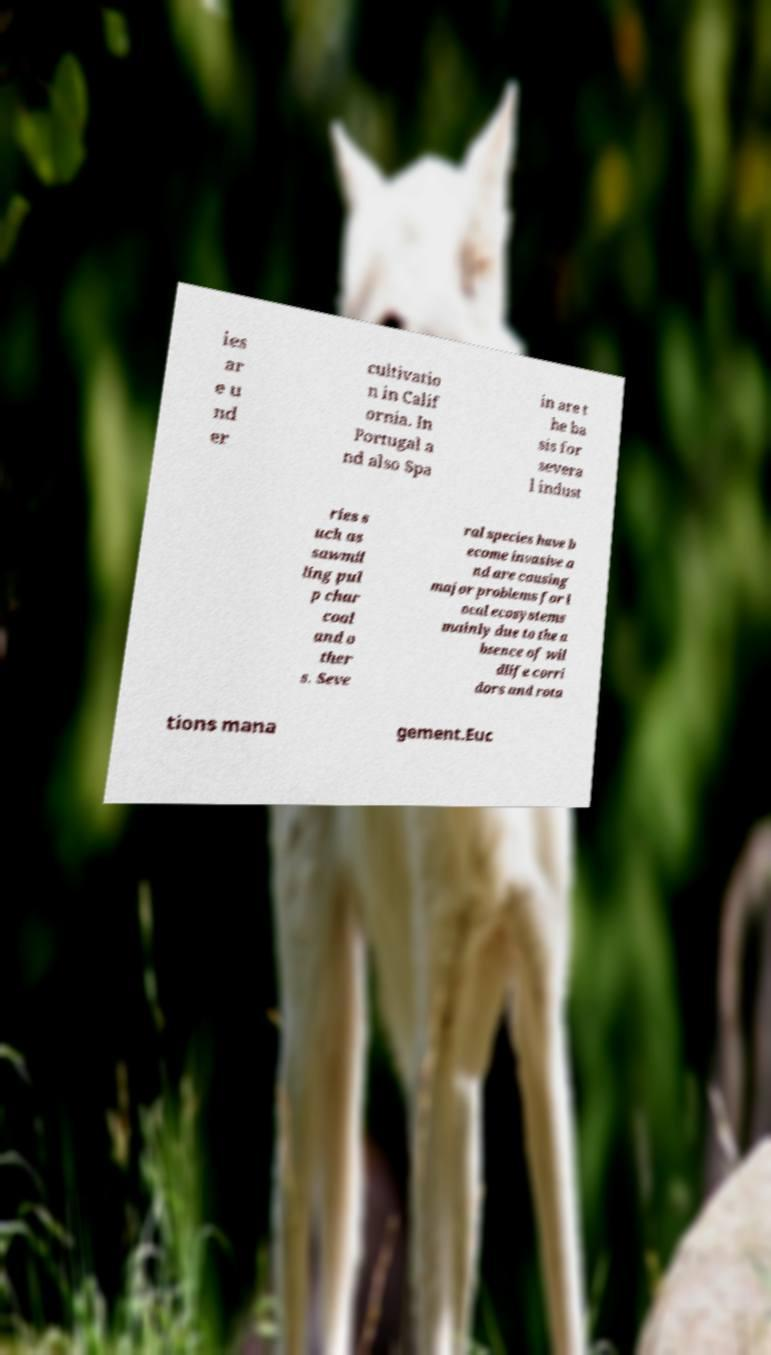Please identify and transcribe the text found in this image. ies ar e u nd er cultivatio n in Calif ornia. In Portugal a nd also Spa in are t he ba sis for severa l indust ries s uch as sawmil ling pul p char coal and o ther s. Seve ral species have b ecome invasive a nd are causing major problems for l ocal ecosystems mainly due to the a bsence of wil dlife corri dors and rota tions mana gement.Euc 